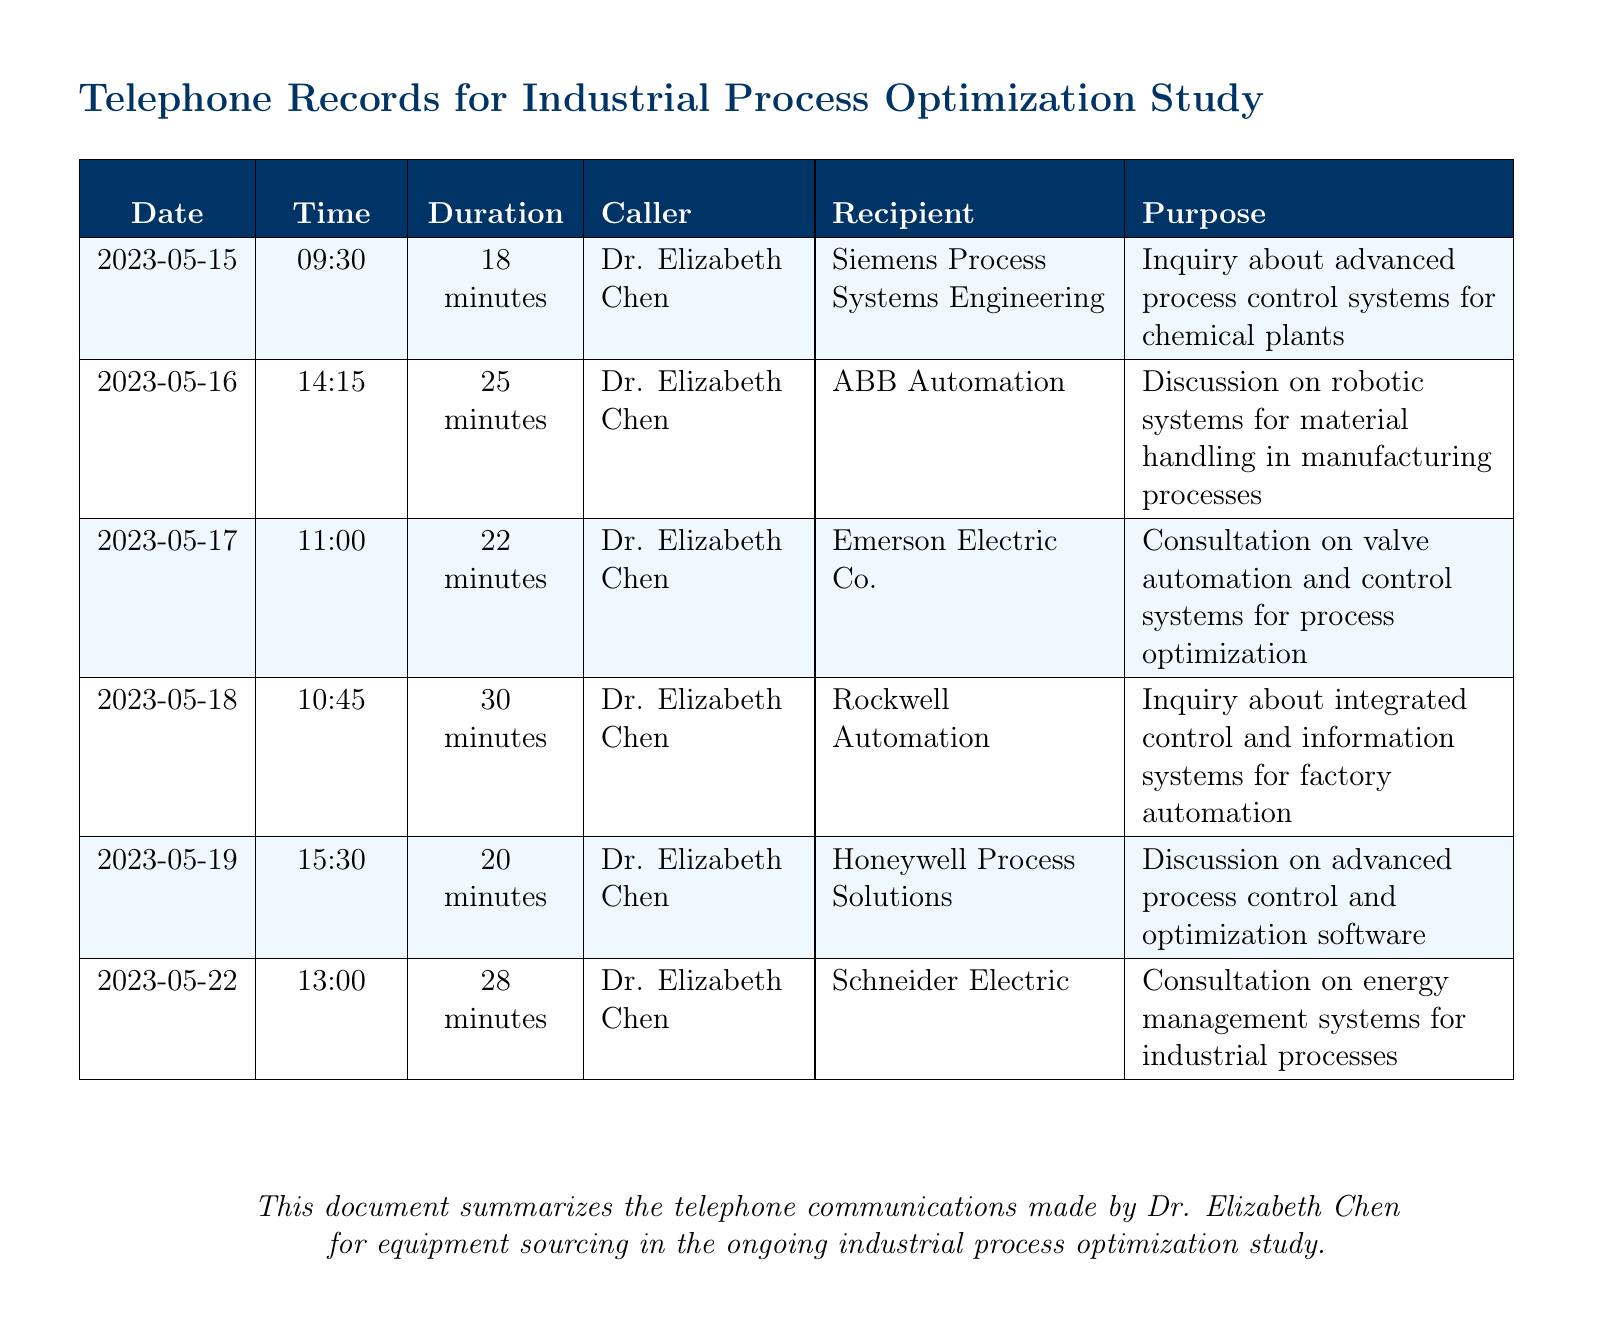What is the purpose of the call made on 2023-05-15? The purpose of the call is stated in the document, which describes it as an inquiry about advanced process control systems for chemical plants.
Answer: Inquiry about advanced process control systems for chemical plants Who was called on 2023-05-19? The recipient of the call on this date is indicated in the document as Honeywell Process Solutions.
Answer: Honeywell Process Solutions How long was the call on 2023-05-18? The duration of the call is mentioned in the document as 30 minutes, which is a specific detail about that communication.
Answer: 30 minutes What was discussed during the call with Siemens Process Systems Engineering? The document specifies that the call with Siemens was about advanced process control systems, requiring comprehension of its details.
Answer: Inquiry about advanced process control systems for chemical plants Which company was consulted regarding energy management systems? The document clearly identifies Schneider Electric as the company consulted about energy management systems in industrial processes.
Answer: Schneider Electric How many calls were made on 2023-05-16? The document indicates that there was one call made on this date, highlighting the specific day.
Answer: One Which caller conducted discussions on robotic systems? The document attributes this discussion specifically to Dr. Elizabeth Chen, making it clear who was involved.
Answer: Dr. Elizabeth Chen What is the total number of companies contacted? The document lists six different companies, providing a clear count of the contacts made during the study.
Answer: Six 